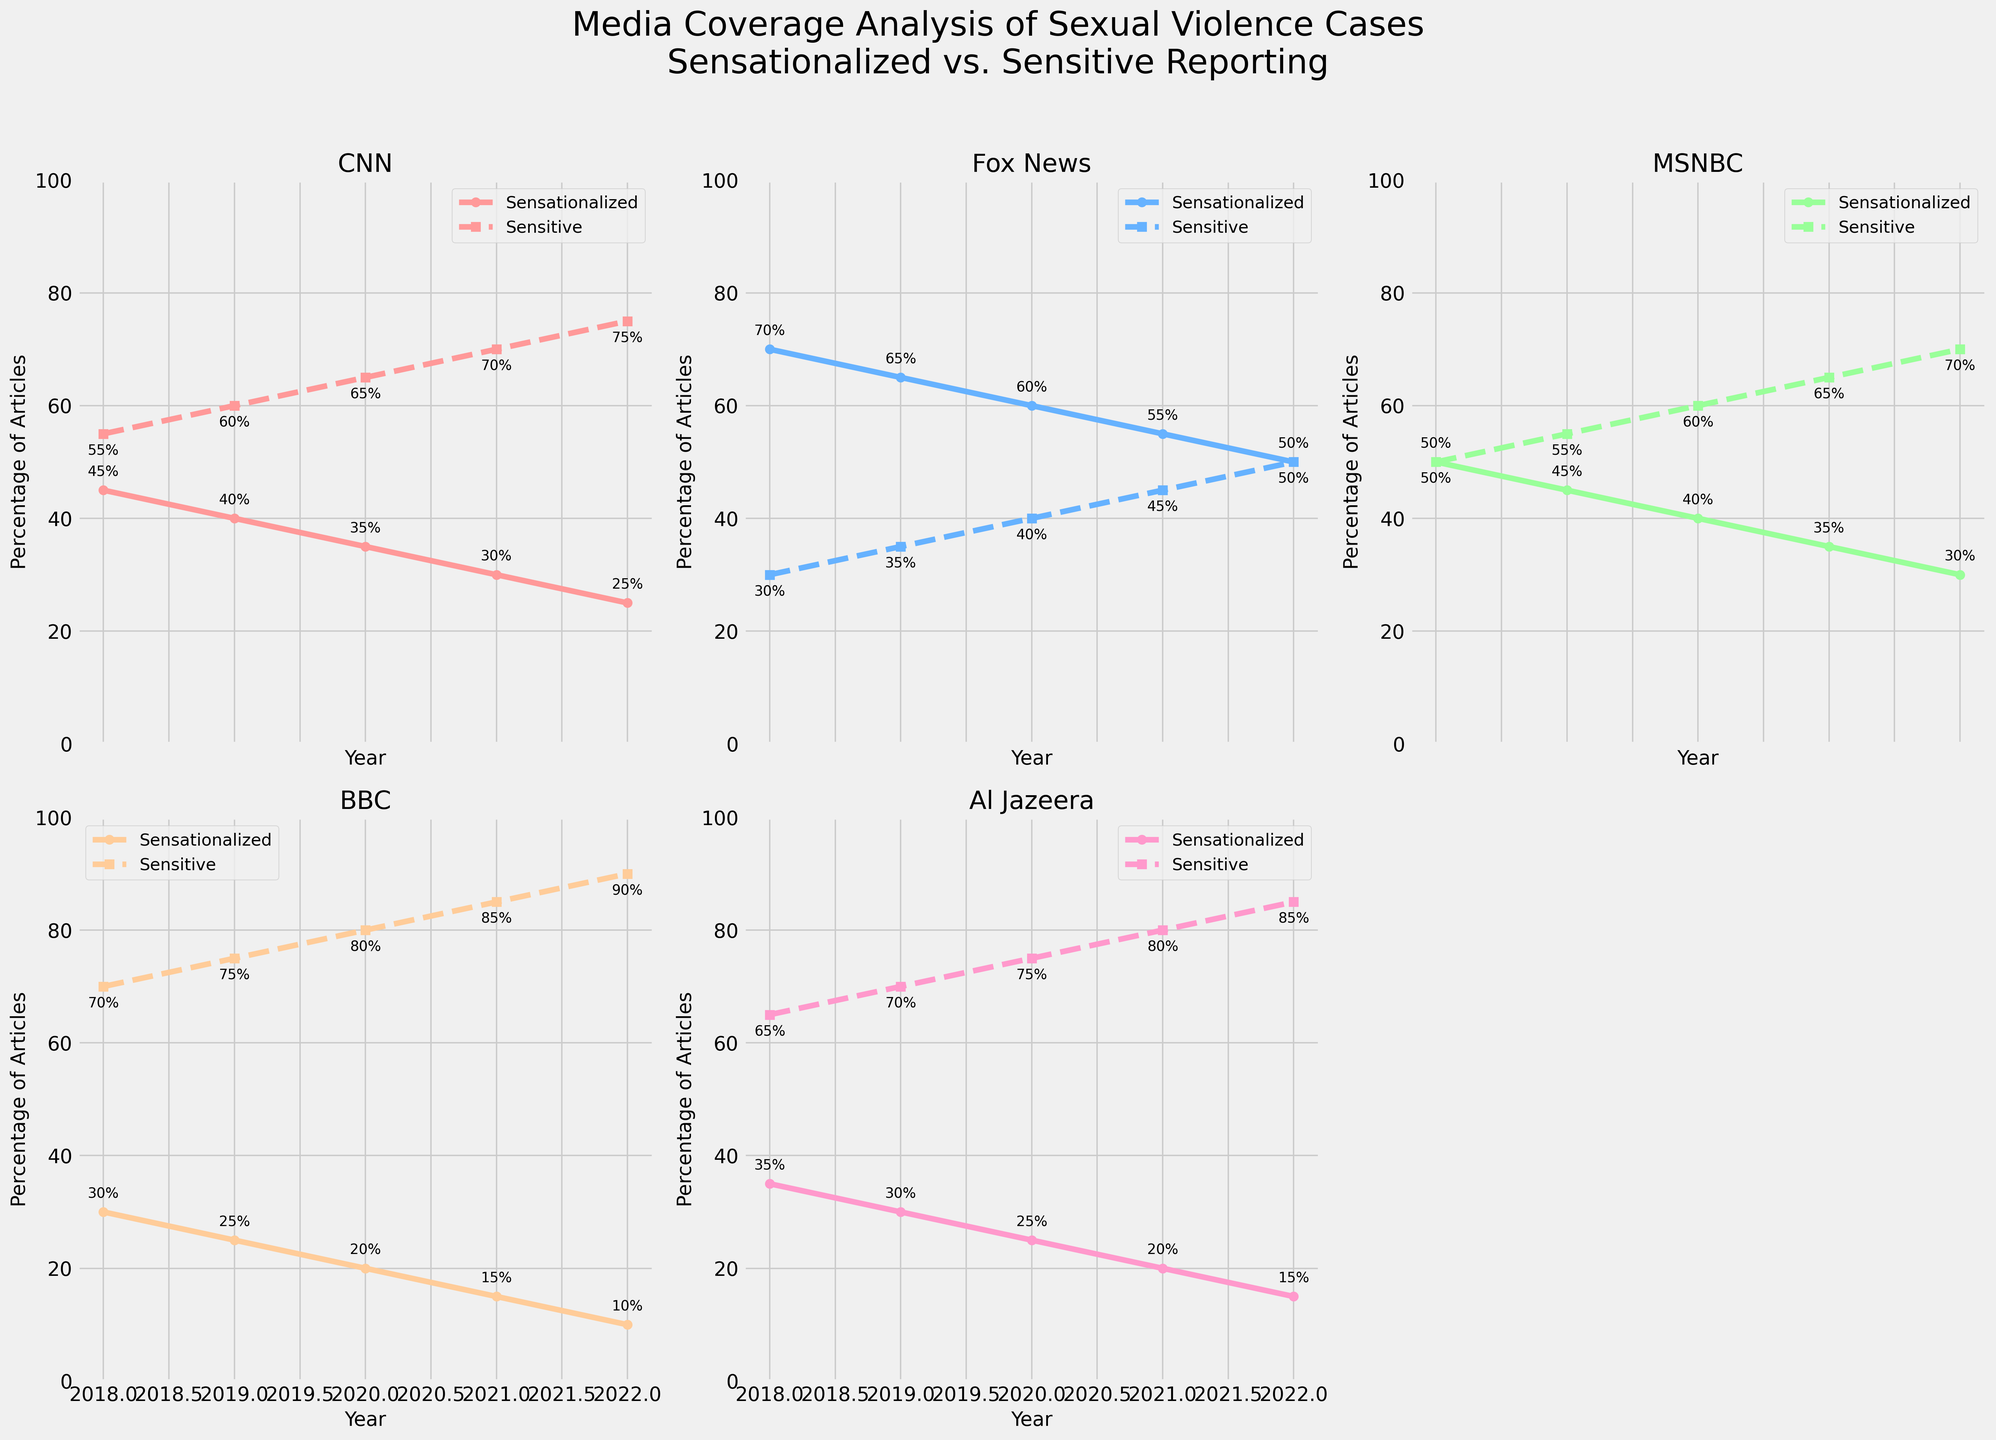What is the percentage drop in sensationalized articles for Fox News from 2018 to 2022? First, identify the sensationalized articles for Fox News in 2018 (70%) and 2022 (50%). Calculate the difference: 70% - 50% = 20%.
Answer: 20% Which news outlet shows the highest percentage of sensitive articles in 2022? The sensitive articles in 2022 are: CNN (75%), Fox News (50%), MSNBC (70%), BBC (90%), Al Jazeera (85%). The highest percentage is from BBC with 90%.
Answer: BBC How does the trend in sensitive reporting for CNN compare to that for MSNBC over the years? For CNN, the percentage of sensitive reporting increases from 55% (2018) to 75% (2022). For MSNBC, the percentage of sensitive reporting increases from 50% (2018) to 70% (2022). Both show an increasing trend, but CNN has a higher increase overall.
Answer: Both increased, with CNN having a higher overall increase What is the average percentage of sensationalized articles for BBC from 2018 to 2022? The percentages of sensationalized articles for BBC are: 2018 (30%), 2019 (25%), 2020 (20%), 2021 (15%), 2022 (10%). The average is calculated as (30 + 25 + 20 + 15 + 10) / 5 = 100 / 5 = 20%.
Answer: 20% Between Al Jazeera and Fox News, which outlet had a greater proportion of sensitive articles in 2020? In 2020, Al Jazeera had 75% sensitive articles while Fox News had 40%. Al Jazeera had a greater proportion of sensitive articles.
Answer: Al Jazeera Compare the overall trend of sensitive reporting between CNN and the BBC from 2018 to 2022. Both CNN and BBC show an increasing trend in sensitive reporting. CNN starts at 55% in 2018 and reaches 75% in 2022, while BBC starts at 70% in 2018 and reaches 90% in 2022. BBC exhibits a larger increase in sensitive reporting.
Answer: Both increased, with BBC showing a larger increase What is the total number of sensitive articles published by MSNBC across all the given years? Each year, MSNBC publishes 100 articles. The percentages of sensitive articles per year are: 2018 (50), 2019 (55), 2020 (60), 2021 (65), 2022 (70). Summing these gives 50 + 55 + 60 + 65 + 70 = 300.
Answer: 300 